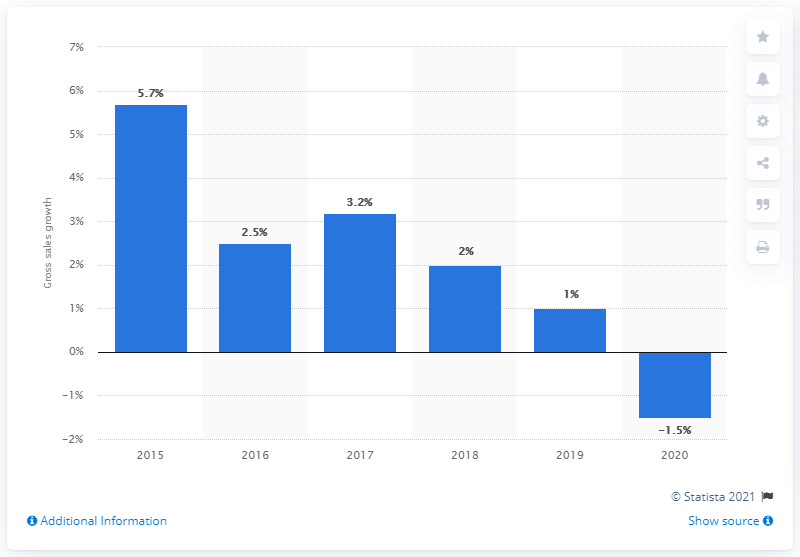Draw attention to some important aspects in this diagram. The sales growth of John Lewis Partnership plc in the UK in 2018 was 3.8%. In 2015, the gross sales of the John Lewis Partnership had grown by 5.7%. The sales growth rate of John Lewis Partnership plc in the UK in 2016 and 2018 was 0.5%. 